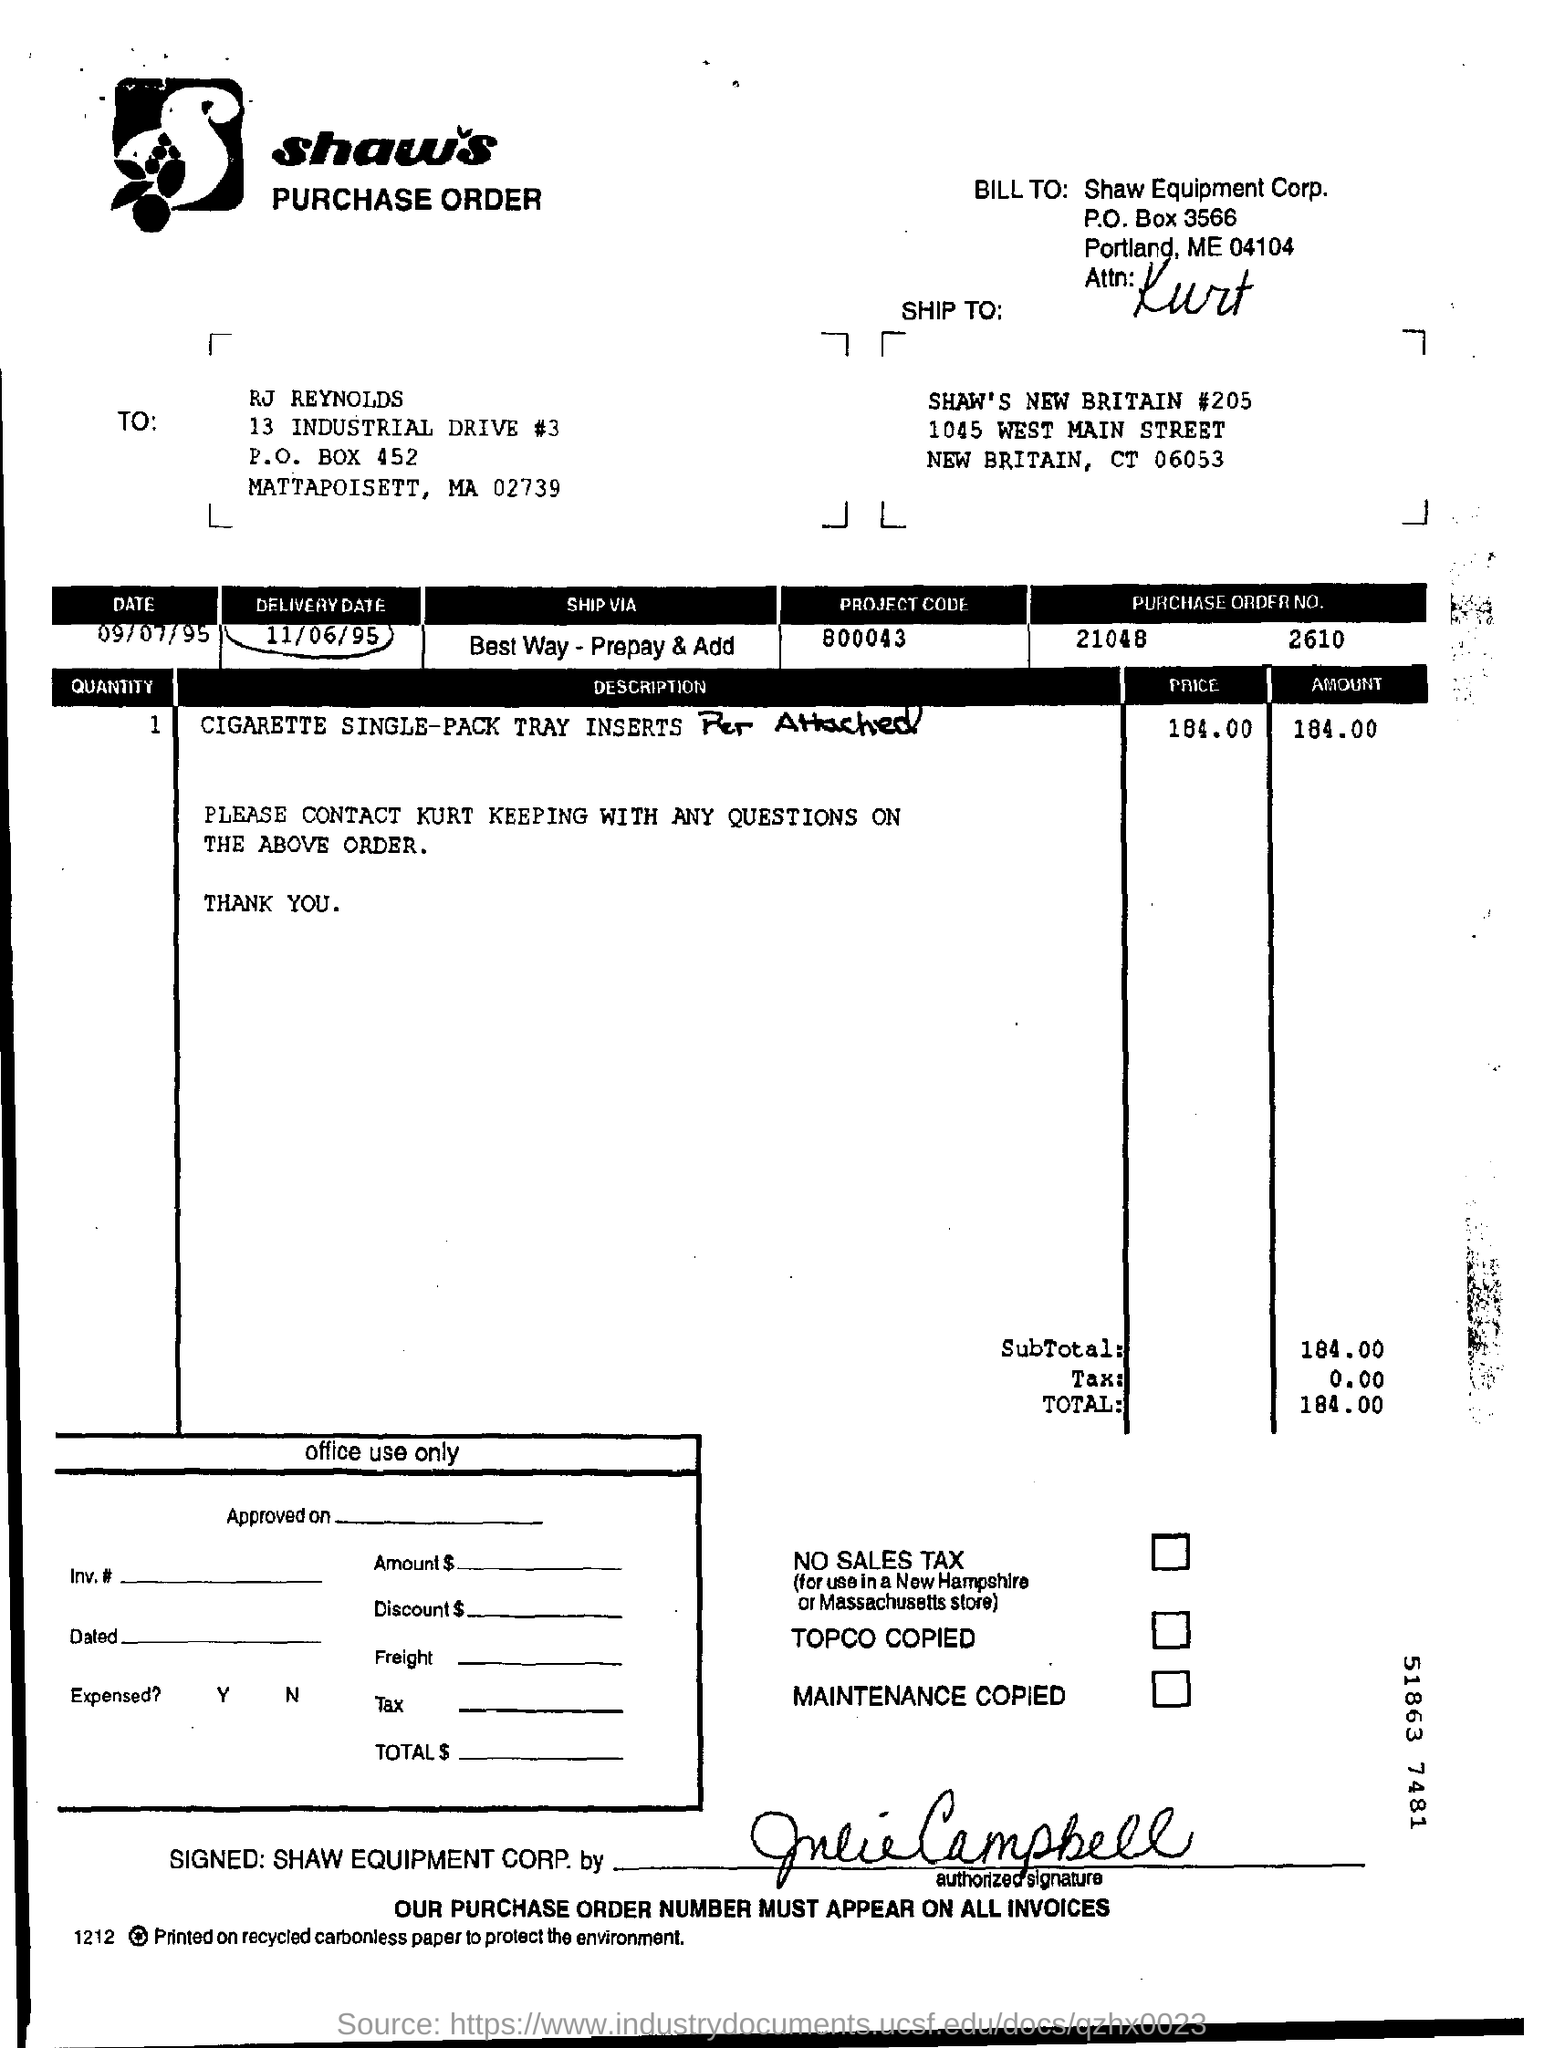Specify some key components in this picture. The P.O. box number for Shaw Equipment Corp is 3566. The project code is 800043... The total is 184.00. I request to mention the delivery date as 11/06/95. 